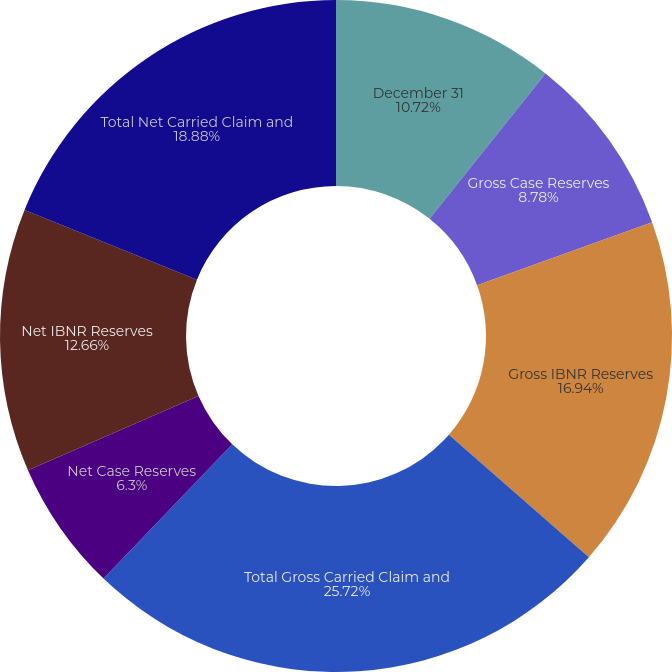Convert chart to OTSL. <chart><loc_0><loc_0><loc_500><loc_500><pie_chart><fcel>December 31<fcel>Gross Case Reserves<fcel>Gross IBNR Reserves<fcel>Total Gross Carried Claim and<fcel>Net Case Reserves<fcel>Net IBNR Reserves<fcel>Total Net Carried Claim and<nl><fcel>10.72%<fcel>8.78%<fcel>16.94%<fcel>25.72%<fcel>6.3%<fcel>12.66%<fcel>18.88%<nl></chart> 